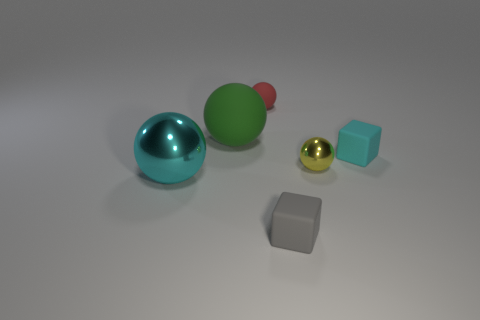Is there a big thing of the same color as the small metallic object?
Your answer should be compact. No. There is a matte object that is to the left of the red matte sphere; is its size the same as the cyan shiny ball?
Make the answer very short. Yes. Is the number of small red cubes less than the number of tiny yellow things?
Provide a succinct answer. Yes. Are there any big cyan things that have the same material as the small cyan cube?
Make the answer very short. No. There is a matte thing that is in front of the tiny cyan cube; what shape is it?
Keep it short and to the point. Cube. Does the shiny sphere to the left of the gray block have the same color as the big matte ball?
Your answer should be compact. No. Is the number of large objects that are behind the large matte ball less than the number of tiny spheres?
Keep it short and to the point. Yes. What is the color of the small cube that is the same material as the gray object?
Provide a short and direct response. Cyan. There is a block behind the small metal sphere; what is its size?
Provide a succinct answer. Small. Is the material of the small cyan cube the same as the large cyan thing?
Your response must be concise. No. 